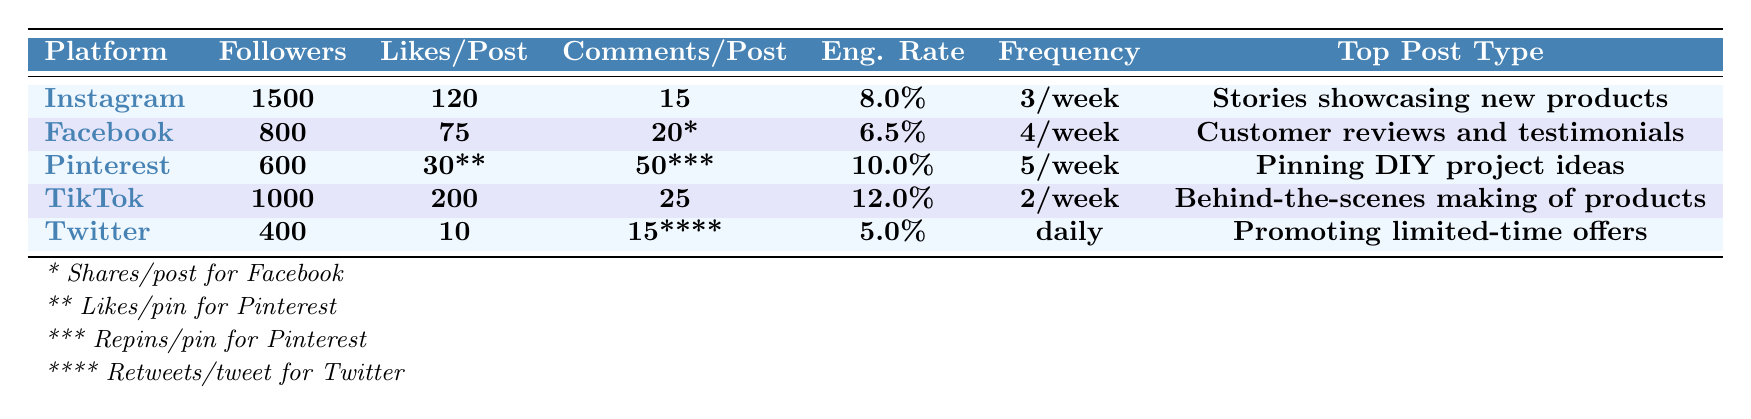What is the average engagement rate across all platforms? The engagement rates are 8.0%, 6.5%, 10.0%, 12.0%, and 5.0%. To find the average, sum these percentages: 8.0 + 6.5 + 10.0 + 12.0 + 5.0 = 41.5. Then, divide by the number of platforms, which is 5. Thus, the average engagement rate is 41.5 / 5 = 8.3%.
Answer: 8.3% Which platform has the highest number of followers? Looking at the follower counts, Instagram has 1500 followers, which is higher than Facebook's 800, Pinterest's 600, TikTok's 1000, and Twitter's 400. Therefore, Instagram has the highest number of followers.
Answer: Instagram How often do you post on TikTok? The table specifies that TikTok posts are made 2 times per week, so the answer can be directly referenced from the table.
Answer: 2 times/week Which platform has the highest average engagement rate? The engagement rates are compared: Instagram (8.0%), Facebook (6.5%), Pinterest (10.0%), TikTok (12.0%), and Twitter (5.0%). TikTok has the highest engagement rate at 12.0%.
Answer: TikTok Is the average engagement rate for Pinterest higher than that of Twitter? Pinterest has an engagement rate of 10.0%, while Twitter's engagement rate is 5.0%. Since 10.0% is greater than 5.0%, the statement is true.
Answer: Yes What is the total number of followers across all platforms? Adding the follower counts: 1500 (Instagram) + 800 (Facebook) + 600 (Pinterest) + 1000 (TikTok) + 400 (Twitter) = 4000.
Answer: 4000 If you doubled your Facebook likes per post, what would they be? Facebook currently has 75 likes per post, so doubling this value gives 75 * 2 = 150 likes per post.
Answer: 150 Which platform has the most unique post type compared to the others? The unique post types listed are: Instagram - Stories showcasing new products, Facebook - Customer reviews and testimonials, Pinterest - Pinning DIY project ideas, TikTok - Behind-the-scenes making of products, and Twitter - Promoting limited-time offers. Since all post types are unique to their respective platforms, the answer is the same for all platforms.
Answer: All platforms have unique post types How do the likes per post on Pinterest compare to those on Facebook? Pinterest has 30 likes per pin, while Facebook has 75 likes per post. Since 30 is less than 75, Pinterest has fewer likes per post compared to Facebook.
Answer: Fewer Which platform has the least number of comments per post? Only Twitter has 15 retweets per tweet, while the others have: Instagram (15), Facebook (20), TikTok (25), Pinterest (50). Since 15 is the least compared to the rest, Twitter is the platform with the least comments.
Answer: Twitter 